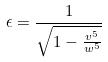Convert formula to latex. <formula><loc_0><loc_0><loc_500><loc_500>\epsilon = \frac { 1 } { \sqrt { 1 - \frac { v ^ { 5 } } { w ^ { 5 } } } }</formula> 